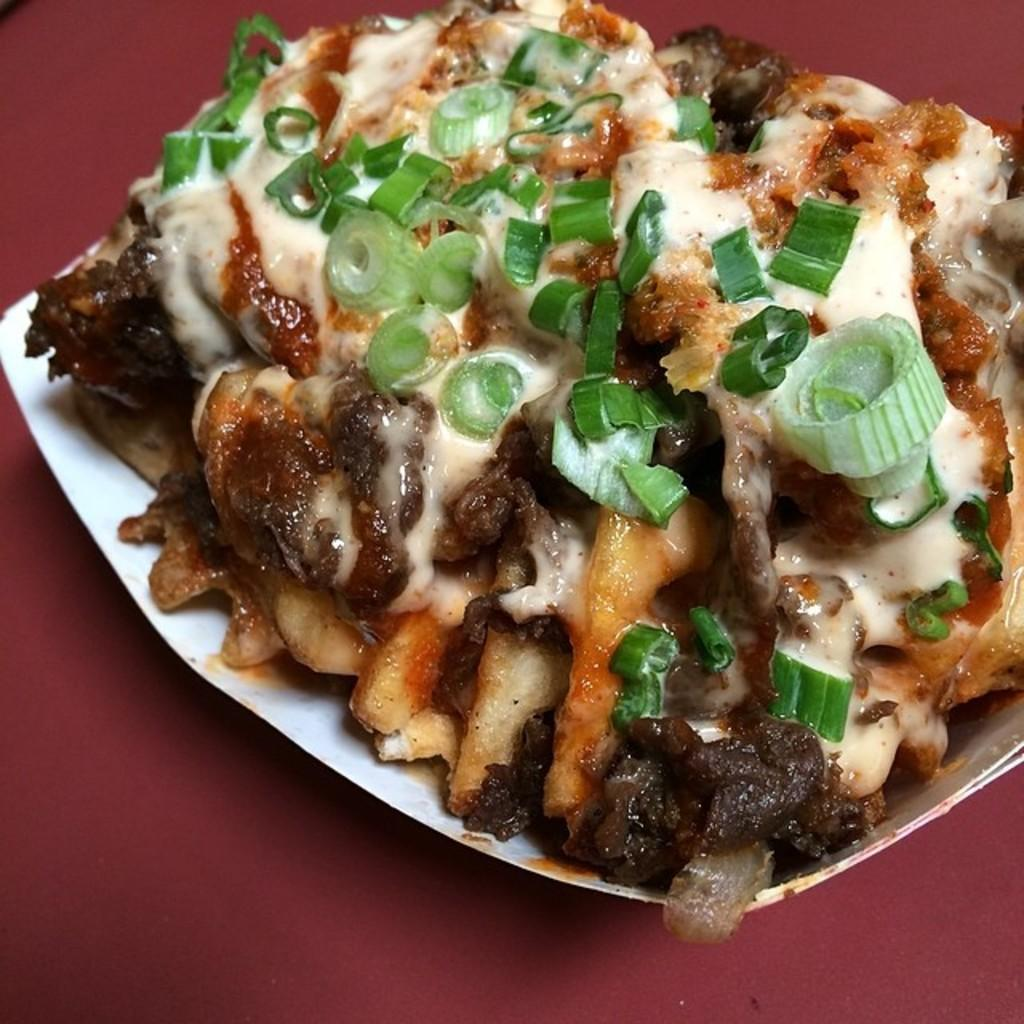What is present on the plate in the image? There is food in a plate in the image. What color of paint is on the shelf in the image? There is no shelf or paint present in the image; it only features a plate of food. 